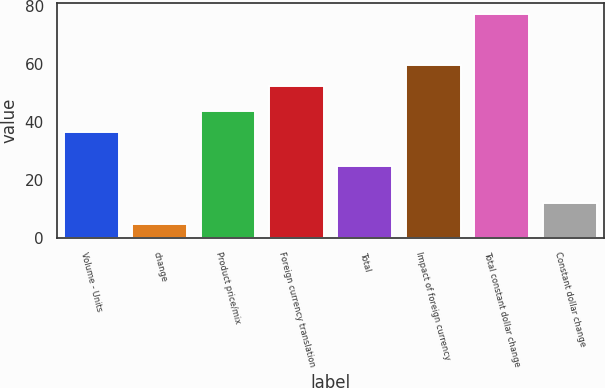Convert chart. <chart><loc_0><loc_0><loc_500><loc_500><bar_chart><fcel>Volume - Units<fcel>change<fcel>Product price/mix<fcel>Foreign currency translation<fcel>Total<fcel>Impact of foreign currency<fcel>Total constant dollar change<fcel>Constant dollar change<nl><fcel>36.5<fcel>4.6<fcel>43.75<fcel>52.5<fcel>24.6<fcel>59.75<fcel>77.1<fcel>11.85<nl></chart> 